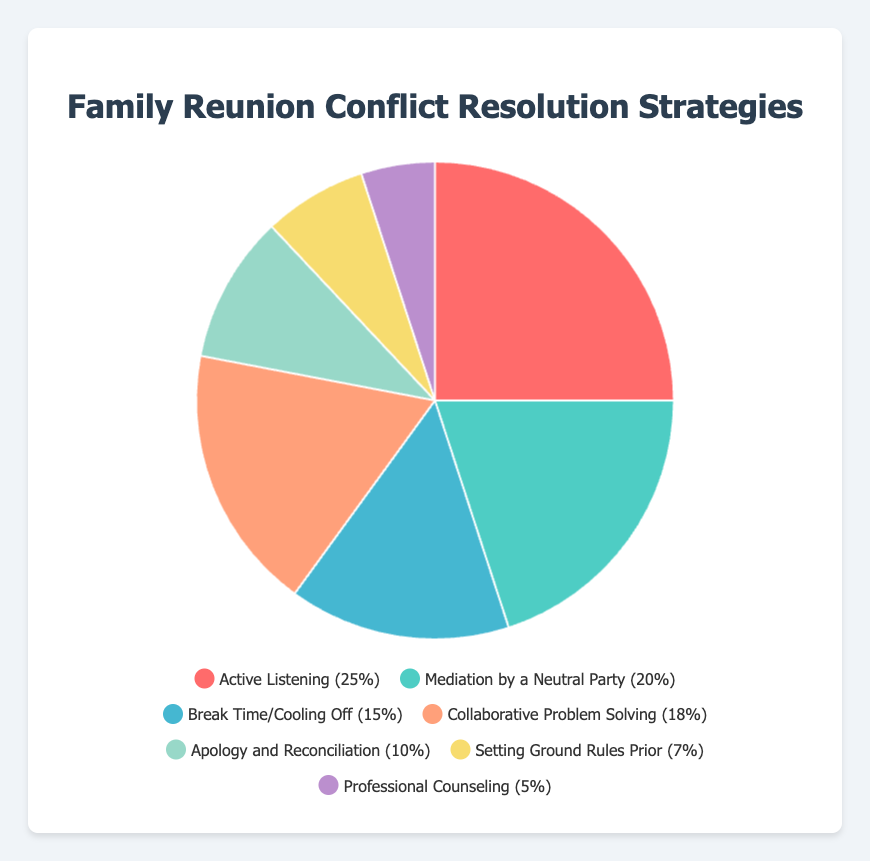Which conflict resolution strategy is used the most during family reunions? To find this answer, look at the largest segment in the pie chart. The segment with the highest percentage is "Active Listening" with 25%.
Answer: Active Listening Which conflict resolution strategy is least used during family reunions? To find the least used strategy, identify the smallest segment in the pie chart. The smallest segment is labeled "Professional Counseling" with 5%.
Answer: Professional Counseling What is the combined relative frequency of "Mediation by a Neutral Party" and "Collaborative Problem Solving"? Add the relative frequencies of "Mediation by a Neutral Party" (20%) and "Collaborative Problem Solving" (18%). 20% + 18% = 38%.
Answer: 38% How much larger is the relative frequency of "Active Listening" compared to "Apology and Reconciliation"? Subtract the relative frequency of "Apology and Reconciliation" (10%) from that of "Active Listening" (25%). 25% - 10% = 15%.
Answer: 15% Between "Break Time/Cooling Off" and "Setting Ground Rules Prior," which strategy has a higher relative frequency? Compare the relative frequencies. "Break Time/Cooling Off" has 15% while "Setting Ground Rules Prior" has 7%. 15% is greater than 7%.
Answer: Break Time/Cooling Off What is the total relative frequency of all strategies that have a frequency of more than 10%? Identify the strategies with more than 10%: "Active Listening" (25%), "Mediation by a Neutral Party" (20%), "Break Time/Cooling Off" (15%), and "Collaborative Problem Solving" (18%). Add these frequencies: 25% + 20% + 15% + 18% = 78%.
Answer: 78% Which conflict resolution strategy is represented by the green segment? Identify the color attributed to green in the pie chart. The green segment represents "Mediation by a Neutral Party" with 20%.
Answer: Mediation by a Neutral Party 